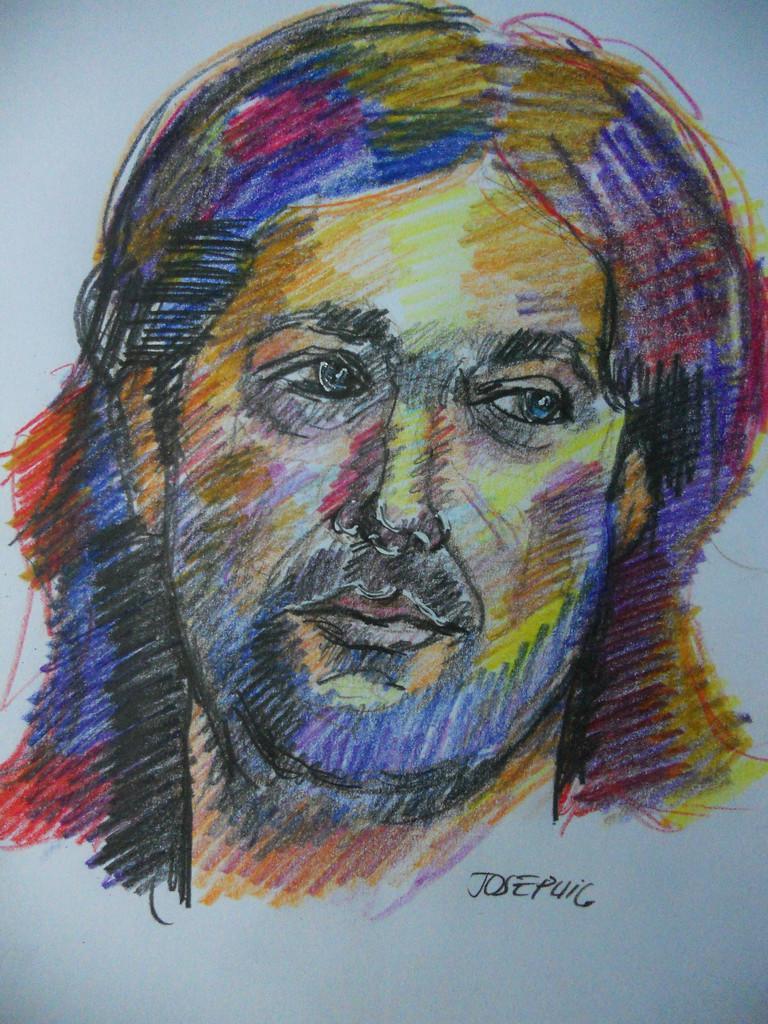Can you describe this image briefly? In this image we can see a colorful drawing of a person's face on the paper. We can also see the name. 